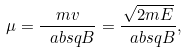Convert formula to latex. <formula><loc_0><loc_0><loc_500><loc_500>\mu = \frac { m v } { \ a b s { q B } } = \frac { \sqrt { 2 m E } } { \ a b s { q B } } ,</formula> 